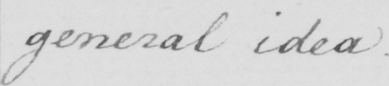Can you read and transcribe this handwriting? general idea . 